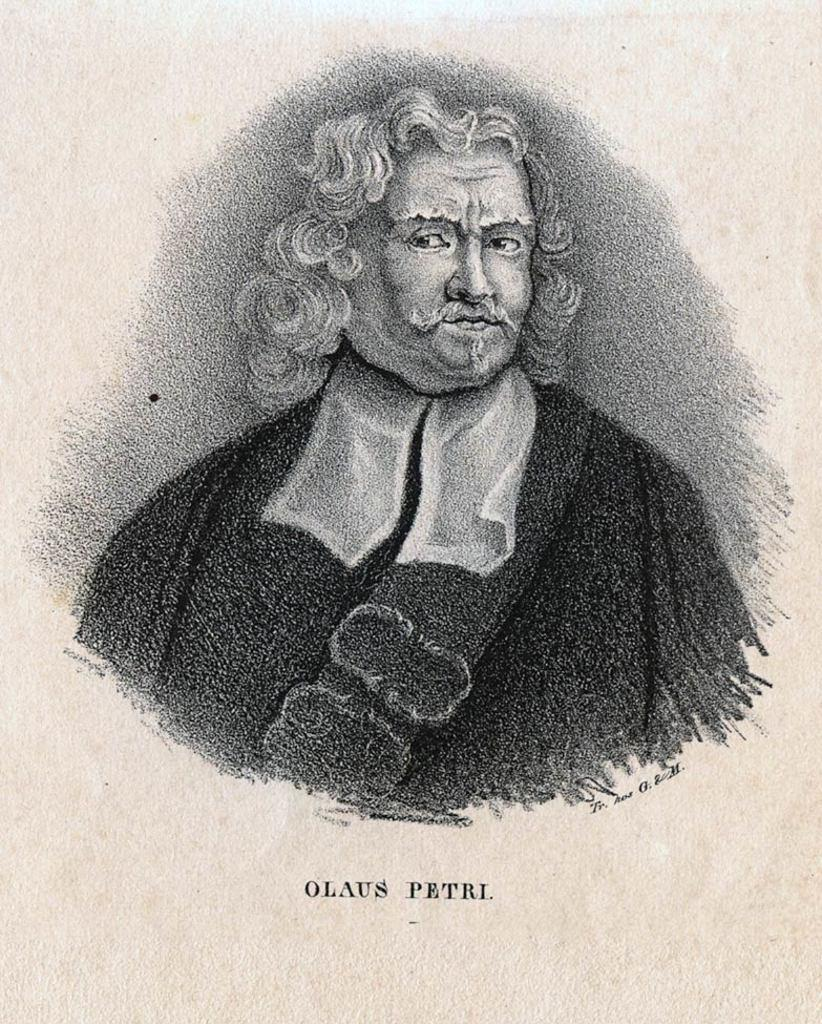What is the main subject of the image? The main subject of the image is a person's painting. What else can be seen in the image besides the painting? There is text in the image. What color is the background of the image? The background of the image is cream-colored. What type of substance is the goose using to fasten the button in the image? There is no goose or button present in the image, so it is not possible to determine what substance might be used to fasten a button. 